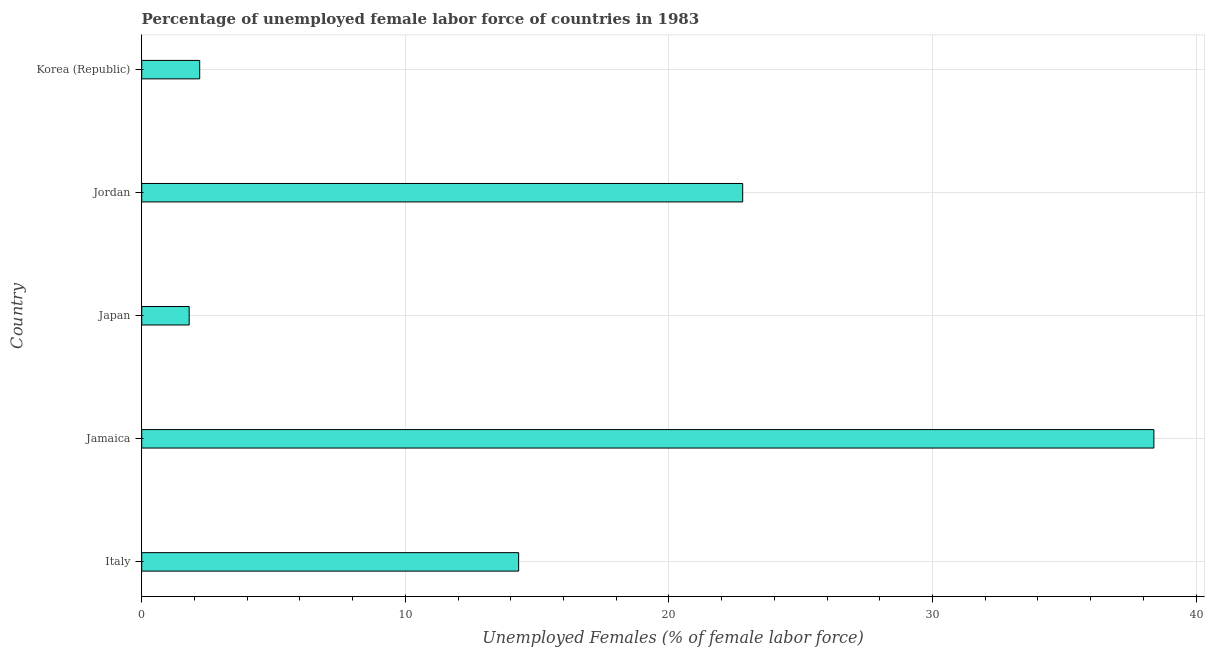What is the title of the graph?
Keep it short and to the point. Percentage of unemployed female labor force of countries in 1983. What is the label or title of the X-axis?
Offer a terse response. Unemployed Females (% of female labor force). What is the label or title of the Y-axis?
Make the answer very short. Country. What is the total unemployed female labour force in Korea (Republic)?
Your answer should be very brief. 2.2. Across all countries, what is the maximum total unemployed female labour force?
Make the answer very short. 38.4. Across all countries, what is the minimum total unemployed female labour force?
Your answer should be very brief. 1.8. In which country was the total unemployed female labour force maximum?
Keep it short and to the point. Jamaica. What is the sum of the total unemployed female labour force?
Make the answer very short. 79.5. What is the average total unemployed female labour force per country?
Give a very brief answer. 15.9. What is the median total unemployed female labour force?
Your response must be concise. 14.3. In how many countries, is the total unemployed female labour force greater than 4 %?
Give a very brief answer. 3. What is the ratio of the total unemployed female labour force in Japan to that in Korea (Republic)?
Give a very brief answer. 0.82. Is the total unemployed female labour force in Jamaica less than that in Jordan?
Your answer should be compact. No. What is the difference between the highest and the lowest total unemployed female labour force?
Your answer should be very brief. 36.6. In how many countries, is the total unemployed female labour force greater than the average total unemployed female labour force taken over all countries?
Provide a short and direct response. 2. Are all the bars in the graph horizontal?
Offer a very short reply. Yes. What is the Unemployed Females (% of female labor force) of Italy?
Your response must be concise. 14.3. What is the Unemployed Females (% of female labor force) in Jamaica?
Make the answer very short. 38.4. What is the Unemployed Females (% of female labor force) in Japan?
Ensure brevity in your answer.  1.8. What is the Unemployed Females (% of female labor force) of Jordan?
Your response must be concise. 22.8. What is the Unemployed Females (% of female labor force) of Korea (Republic)?
Your answer should be very brief. 2.2. What is the difference between the Unemployed Females (% of female labor force) in Italy and Jamaica?
Provide a short and direct response. -24.1. What is the difference between the Unemployed Females (% of female labor force) in Italy and Japan?
Make the answer very short. 12.5. What is the difference between the Unemployed Females (% of female labor force) in Jamaica and Japan?
Offer a very short reply. 36.6. What is the difference between the Unemployed Females (% of female labor force) in Jamaica and Jordan?
Your answer should be compact. 15.6. What is the difference between the Unemployed Females (% of female labor force) in Jamaica and Korea (Republic)?
Make the answer very short. 36.2. What is the difference between the Unemployed Females (% of female labor force) in Japan and Jordan?
Give a very brief answer. -21. What is the difference between the Unemployed Females (% of female labor force) in Japan and Korea (Republic)?
Your response must be concise. -0.4. What is the difference between the Unemployed Females (% of female labor force) in Jordan and Korea (Republic)?
Provide a succinct answer. 20.6. What is the ratio of the Unemployed Females (% of female labor force) in Italy to that in Jamaica?
Your response must be concise. 0.37. What is the ratio of the Unemployed Females (% of female labor force) in Italy to that in Japan?
Ensure brevity in your answer.  7.94. What is the ratio of the Unemployed Females (% of female labor force) in Italy to that in Jordan?
Ensure brevity in your answer.  0.63. What is the ratio of the Unemployed Females (% of female labor force) in Italy to that in Korea (Republic)?
Offer a terse response. 6.5. What is the ratio of the Unemployed Females (% of female labor force) in Jamaica to that in Japan?
Ensure brevity in your answer.  21.33. What is the ratio of the Unemployed Females (% of female labor force) in Jamaica to that in Jordan?
Offer a very short reply. 1.68. What is the ratio of the Unemployed Females (% of female labor force) in Jamaica to that in Korea (Republic)?
Your answer should be very brief. 17.45. What is the ratio of the Unemployed Females (% of female labor force) in Japan to that in Jordan?
Give a very brief answer. 0.08. What is the ratio of the Unemployed Females (% of female labor force) in Japan to that in Korea (Republic)?
Your response must be concise. 0.82. What is the ratio of the Unemployed Females (% of female labor force) in Jordan to that in Korea (Republic)?
Keep it short and to the point. 10.36. 